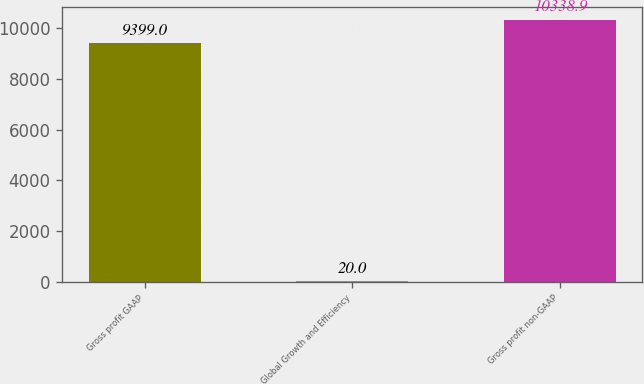Convert chart to OTSL. <chart><loc_0><loc_0><loc_500><loc_500><bar_chart><fcel>Gross profit GAAP<fcel>Global Growth and Efficiency<fcel>Gross profit non-GAAP<nl><fcel>9399<fcel>20<fcel>10338.9<nl></chart> 